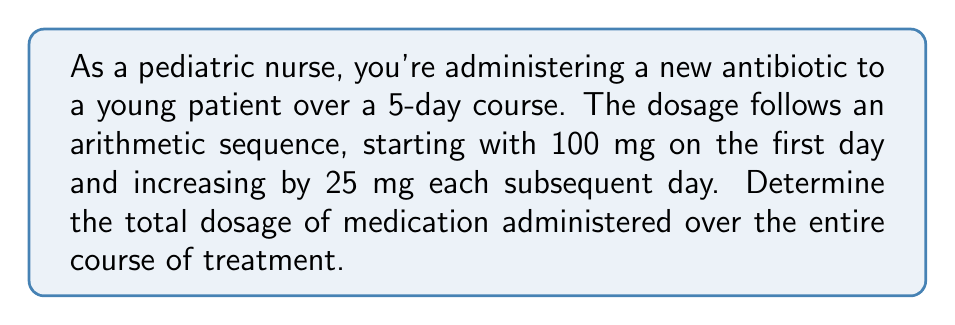Provide a solution to this math problem. Let's approach this step-by-step using the arithmetic sequence formula:

1) First, identify the components of the arithmetic sequence:
   $a_1 = 100$ mg (first term)
   $d = 25$ mg (common difference)
   $n = 5$ (number of terms, as it's a 5-day course)

2) The arithmetic sequence formula for the nth term is:
   $a_n = a_1 + (n-1)d$

3) We can find the last term ($a_5$) using this formula:
   $a_5 = 100 + (5-1)25 = 100 + 100 = 200$ mg

4) To find the sum of an arithmetic sequence, we use the formula:
   $S_n = \frac{n}{2}(a_1 + a_n)$

   Where $S_n$ is the sum of the sequence, $n$ is the number of terms, $a_1$ is the first term, and $a_n$ is the last term.

5) Substituting our values:
   $S_5 = \frac{5}{2}(100 + 200)$

6) Simplify:
   $S_5 = \frac{5}{2}(300) = 750$ mg

Therefore, the total dosage administered over the 5-day course is 750 mg.
Answer: $750$ mg 